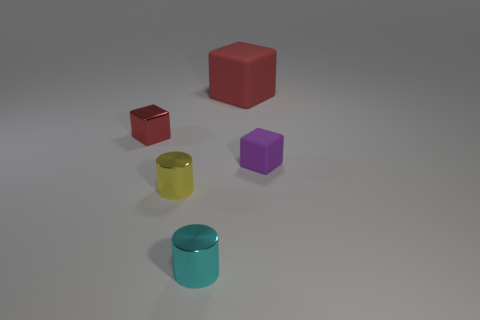Add 2 big yellow things. How many objects exist? 7 Subtract all cubes. How many objects are left? 2 Add 5 red rubber cubes. How many red rubber cubes are left? 6 Add 4 tiny metal objects. How many tiny metal objects exist? 7 Subtract 0 brown spheres. How many objects are left? 5 Subtract all tiny shiny cubes. Subtract all big rubber things. How many objects are left? 3 